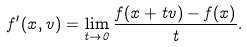Convert formula to latex. <formula><loc_0><loc_0><loc_500><loc_500>f ^ { \prime } ( x , v ) = \lim _ { t \to 0 } \frac { f ( x + t v ) - f ( x ) } { t } .</formula> 